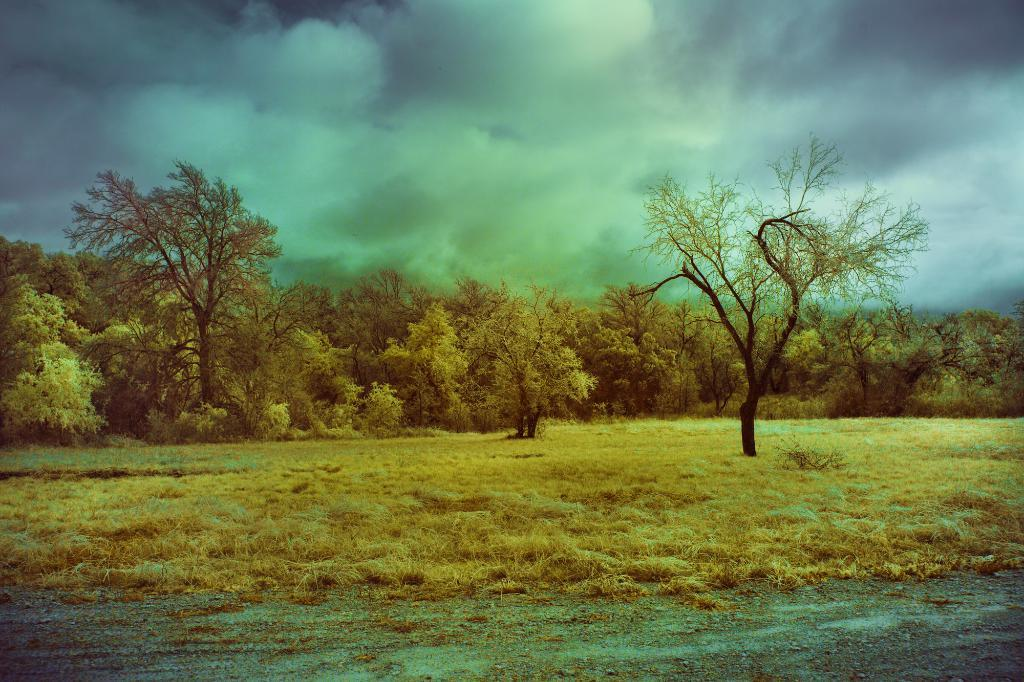What type of vegetation can be seen in the image? There are trees with branches and leaves in the image. What type of ground cover is visible in the image? There is grass visible in the image. What can be seen in the sky in the image? Clouds are present in the sky. How many servants are visible in the image? There are no servants present in the image. What type of home can be seen in the image? There is no home visible in the image; it primarily features natural elements such as trees, grass, and clouds. 